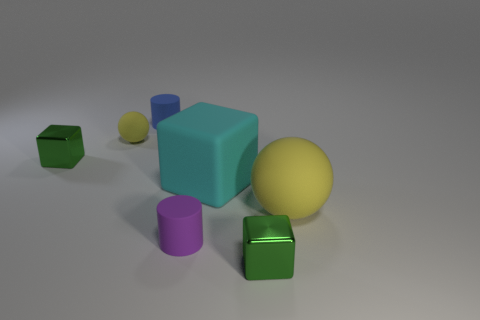Subtract all large rubber cubes. How many cubes are left? 2 Add 1 big things. How many objects exist? 8 Subtract all blue cylinders. How many green cubes are left? 2 Subtract all blue cylinders. How many cylinders are left? 1 Subtract all blocks. How many objects are left? 4 Add 7 large yellow balls. How many large yellow balls exist? 8 Subtract 0 purple cubes. How many objects are left? 7 Subtract all purple spheres. Subtract all green cubes. How many spheres are left? 2 Subtract all blue matte objects. Subtract all cubes. How many objects are left? 3 Add 2 blue rubber objects. How many blue rubber objects are left? 3 